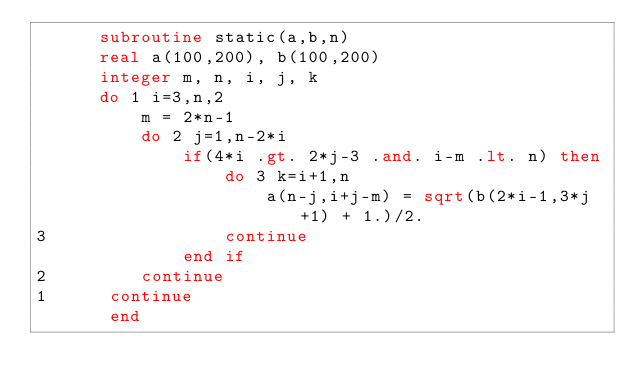<code> <loc_0><loc_0><loc_500><loc_500><_FORTRAN_>      subroutine static(a,b,n)
      real a(100,200), b(100,200)
      integer m, n, i, j, k
      do 1 i=3,n,2
          m = 2*n-1
          do 2 j=1,n-2*i
              if(4*i .gt. 2*j-3 .and. i-m .lt. n) then
                  do 3 k=i+1,n
                      a(n-j,i+j-m) = sqrt(b(2*i-1,3*j+1) + 1.)/2.
3                 continue
              end if
2         continue
1      continue
       end
</code> 